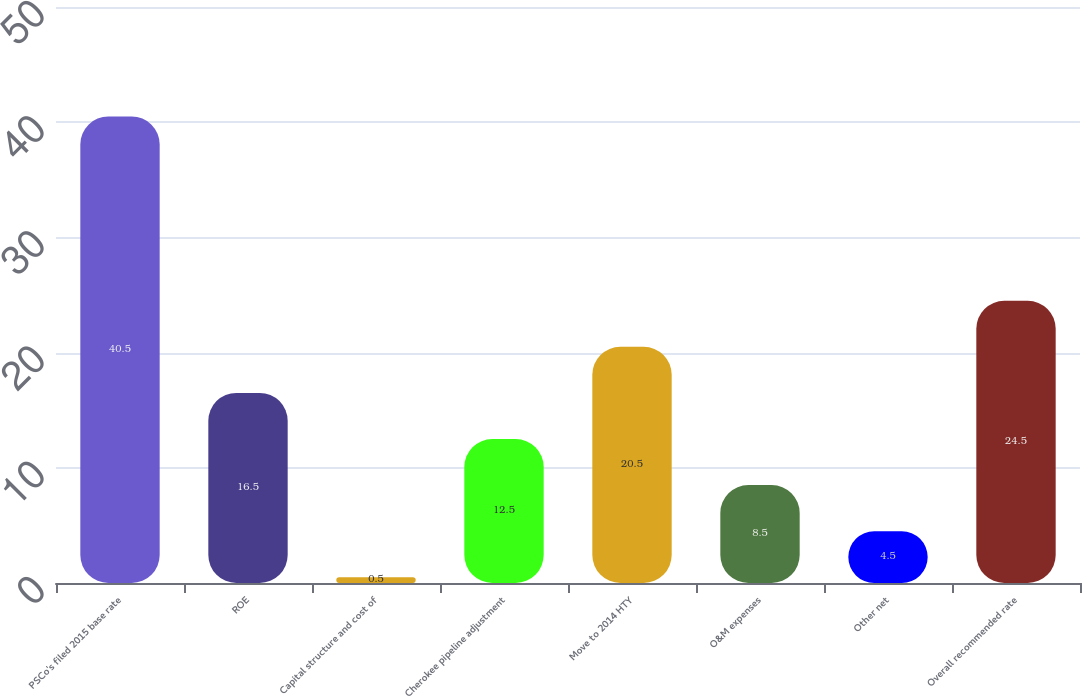Convert chart. <chart><loc_0><loc_0><loc_500><loc_500><bar_chart><fcel>PSCo's filed 2015 base rate<fcel>ROE<fcel>Capital structure and cost of<fcel>Cherokee pipeline adjustment<fcel>Move to 2014 HTY<fcel>O&M expenses<fcel>Other net<fcel>Overall recommended rate<nl><fcel>40.5<fcel>16.5<fcel>0.5<fcel>12.5<fcel>20.5<fcel>8.5<fcel>4.5<fcel>24.5<nl></chart> 